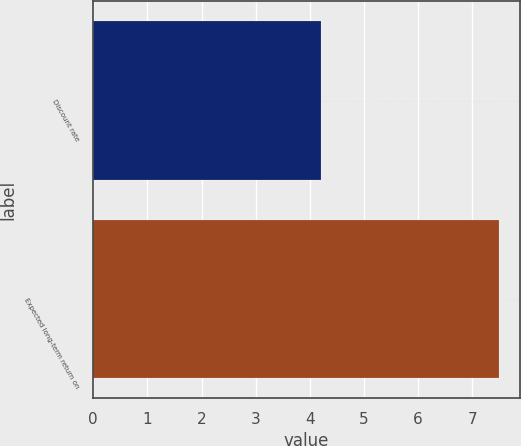<chart> <loc_0><loc_0><loc_500><loc_500><bar_chart><fcel>Discount rate<fcel>Expected long-term return on<nl><fcel>4.2<fcel>7.5<nl></chart> 